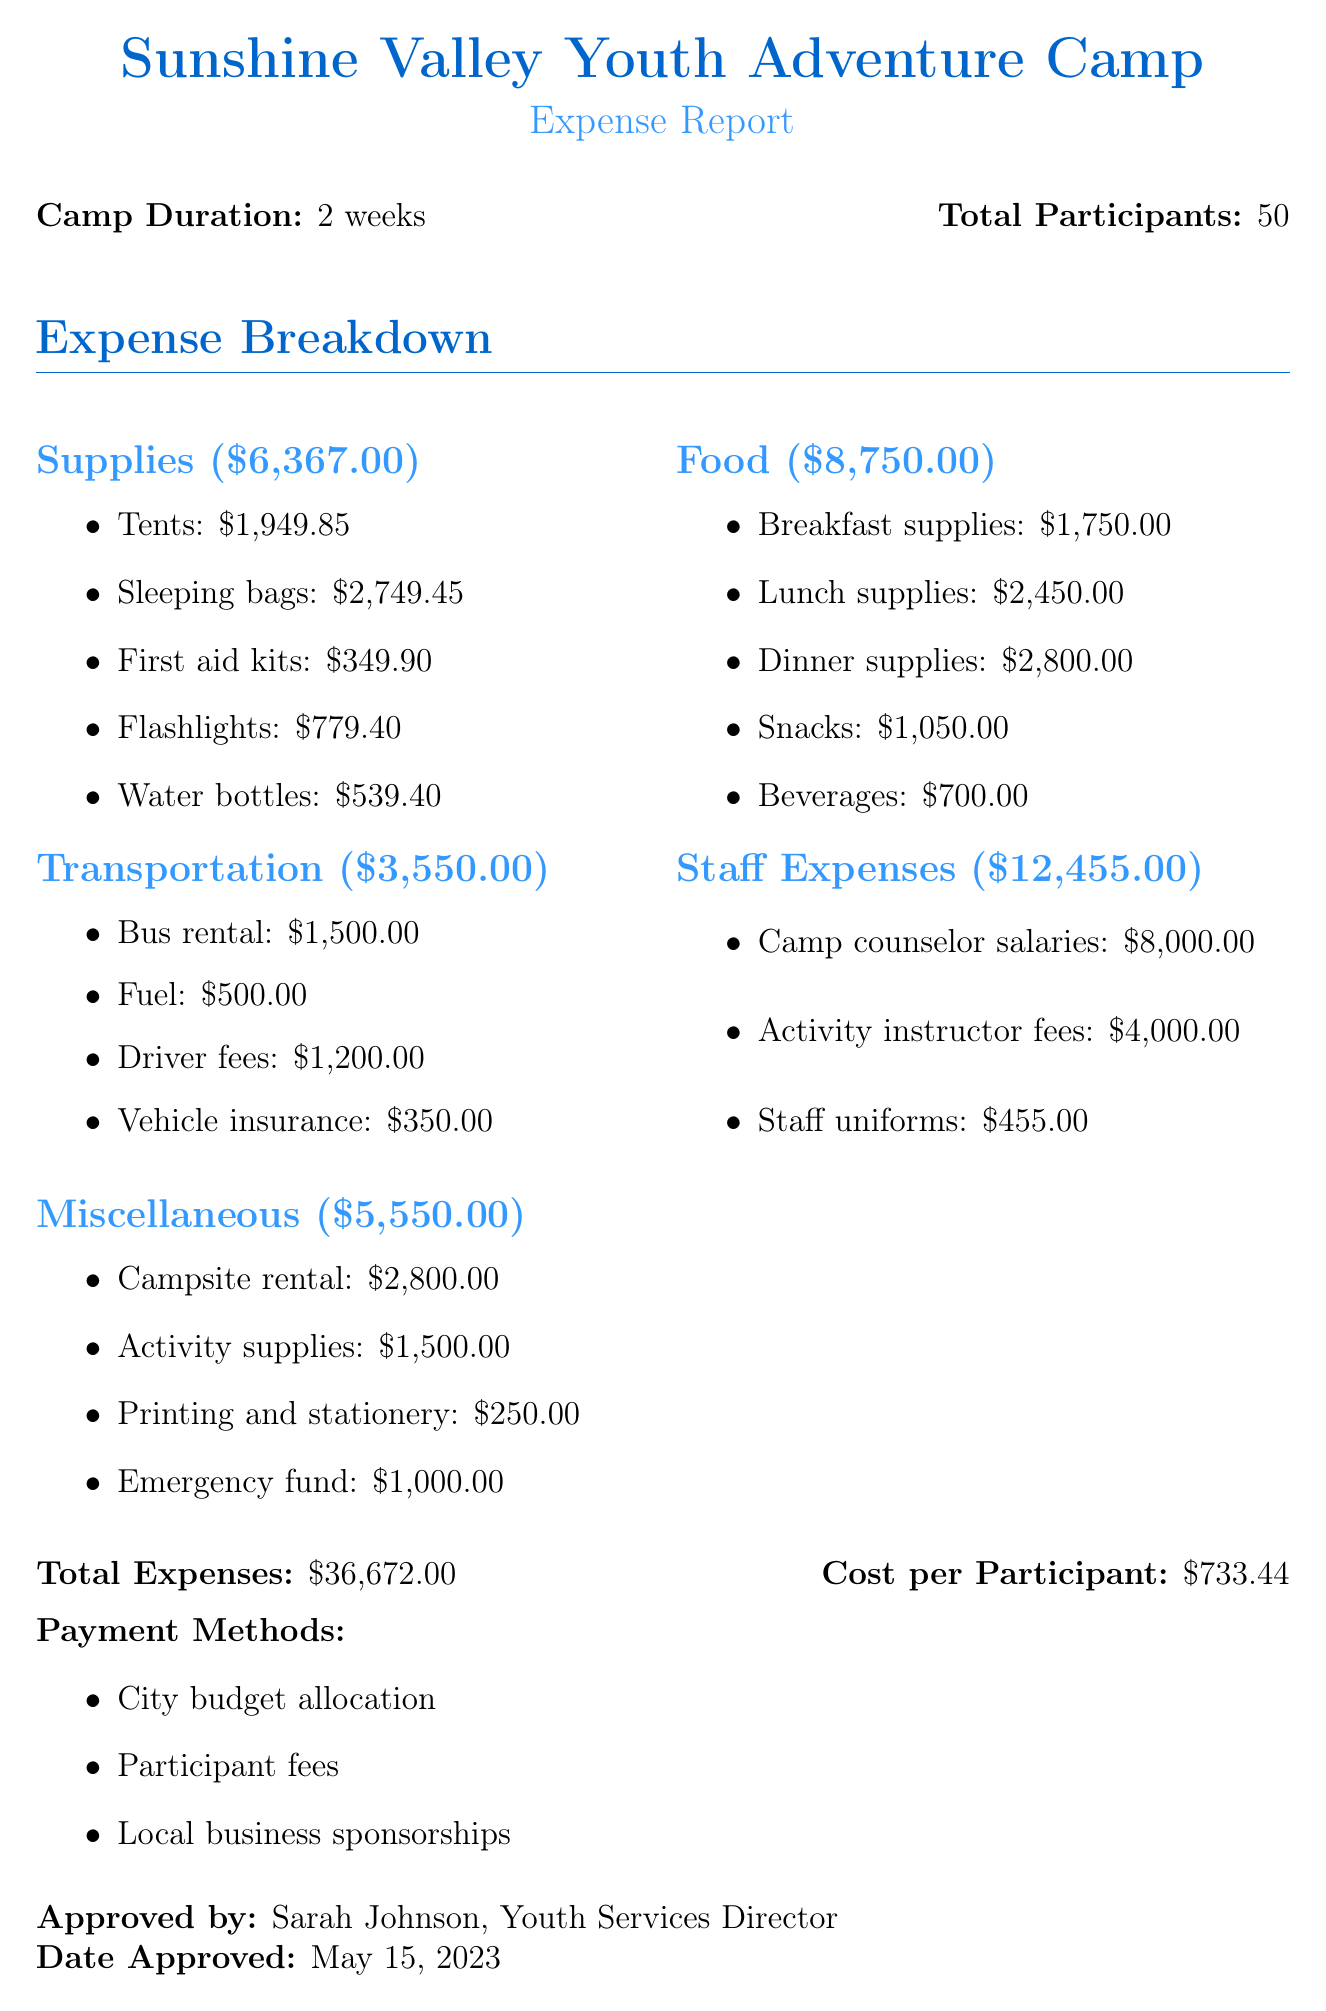What is the camp name? The camp name is mentioned at the top of the document.
Answer: Sunshine Valley Youth Adventure Camp How long is the camp duration? The duration of the camp is specified in the document.
Answer: 2 weeks How many total participants were there? The total number of participants is provided in the document.
Answer: 50 What is the subtotal for the Food category? The subtotal for the Food category is listed in the expense breakdown section.
Answer: 8750.00 What is the total expenses amount? The total expenses are clearly stated at the bottom of the expense report.
Answer: 36672.00 What is the cost per participant? The document specifies the cost per participant calculated from the total expenses.
Answer: 733.44 How many tents were purchased? The number of tents can be found under the Supplies section.
Answer: 15 Who approved the expense report? The person's name who approved the document is mentioned at the end.
Answer: Sarah Johnson What were the payment methods listed? The document enumerates the payment methods used for covering the expenses.
Answer: City budget allocation, Participant fees, Local business sponsorships 